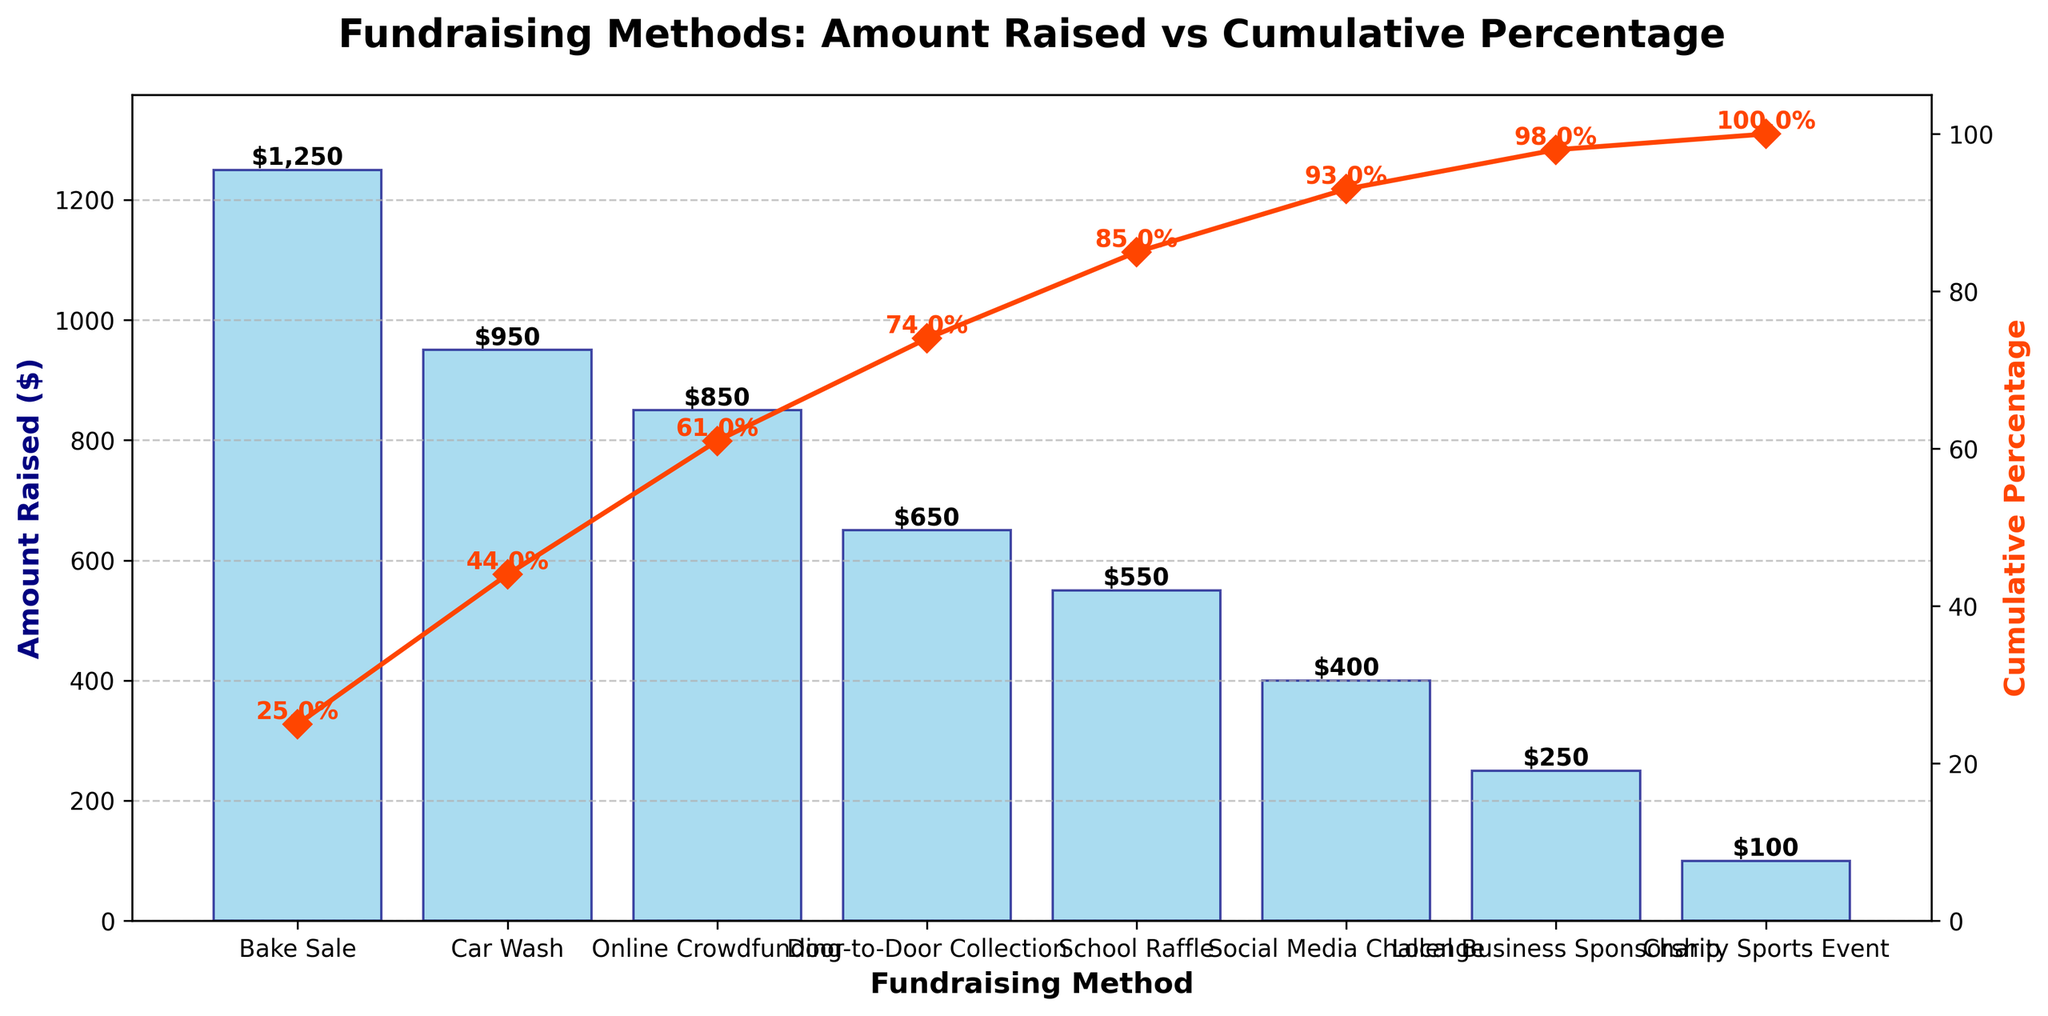What is the title of the chart? The title of the chart is shown at the top, indicating the overall subject of the figure.
Answer: Fundraising Methods: Amount Raised vs Cumulative Percentage How much money was raised by the Bake Sale? The amount raised is represented by bars on the chart. Find the bar labeled 'Bake Sale' and read its height.
Answer: $1250 Which fundraising method contributed the least to the total amount raised? Identify the shortest bar in the chart, which represents the fundraising method that contributed the least amount.
Answer: Charity Sports Event What is the cumulative percentage after the top three fundraising methods? Add up the cumulative percentages listed for the top three methods: Bake Sale (25.0%), Car Wash (44.0%), and Online Crowdfunding (61.0%).
Answer: 61.0% How does the School Raffle compare to the Car Wash in terms of the amount raised? Look at the heights of the bars for the School Raffle and the Car Wash and compare them.
Answer: The School Raffle raised less money than the Car Wash What percentage of the total funds was raised by Door-to-Door Collection and Local Business Sponsorship combined? Add the amounts for Door-to-Door Collection ($650) and Local Business Sponsorship ($250), and calculate their combined percentage based on the total amount.
Answer: 18.0% Which fundraising method represents the largest increase in cumulative percentage? Examine the cumulative percentages and look for the largest jump between consecutive entries.
Answer: Bake Sale How does the amount raised by the Social Media Challenge compare to that of the Online Crowdfunding? Compare the heights of the bars for both fundraising methods.
Answer: The Social Media Challenge raised less than Online Crowdfunding What is the total amount of money raised by all the fundraising methods combined? Sum the values of all the bars representing the amounts raised.
Answer: $5000 What is the cumulative percentage after the School Raffle? Look at the cumulative percentage value corresponding to the School Raffle in the figure.
Answer: 85.0% 